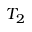<formula> <loc_0><loc_0><loc_500><loc_500>T _ { 2 }</formula> 